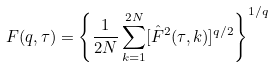<formula> <loc_0><loc_0><loc_500><loc_500>F ( q , \tau ) = \left \{ \frac { 1 } { 2 N } \sum ^ { 2 N } _ { k = 1 } [ \hat { F } ^ { 2 } ( \tau , k ) ] ^ { q / 2 } \right \} ^ { 1 / q }</formula> 